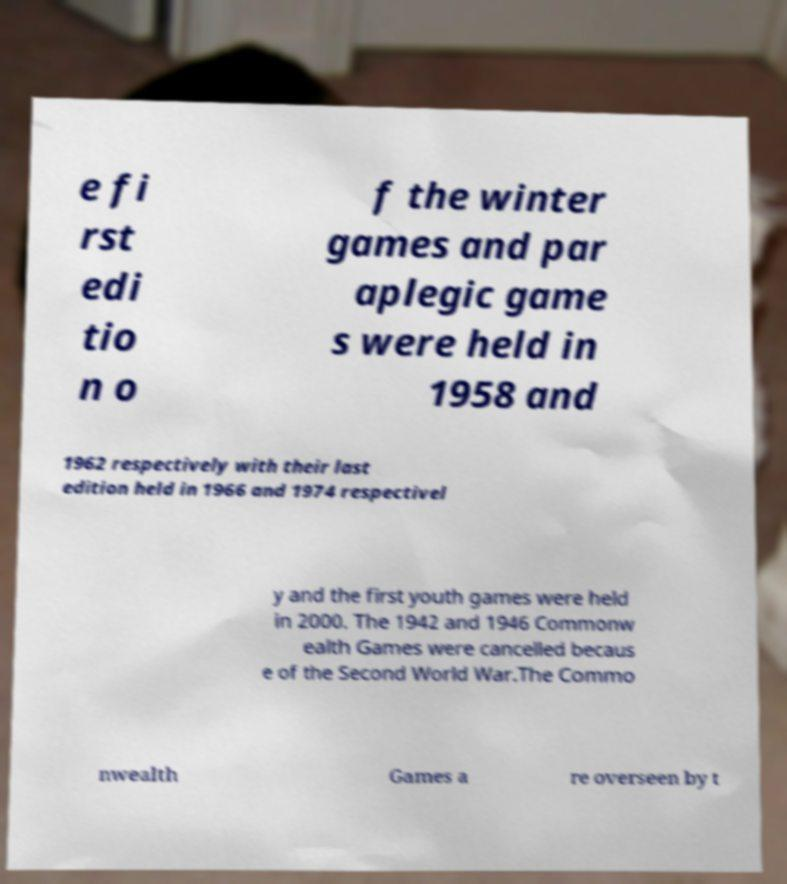For documentation purposes, I need the text within this image transcribed. Could you provide that? e fi rst edi tio n o f the winter games and par aplegic game s were held in 1958 and 1962 respectively with their last edition held in 1966 and 1974 respectivel y and the first youth games were held in 2000. The 1942 and 1946 Commonw ealth Games were cancelled becaus e of the Second World War.The Commo nwealth Games a re overseen by t 